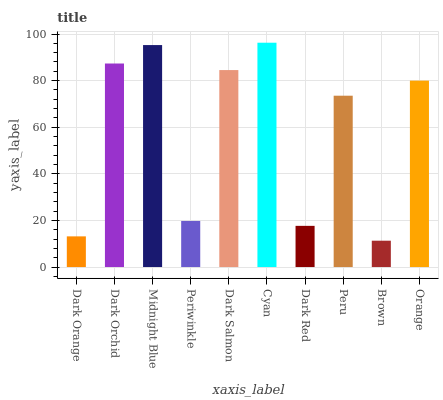Is Brown the minimum?
Answer yes or no. Yes. Is Cyan the maximum?
Answer yes or no. Yes. Is Dark Orchid the minimum?
Answer yes or no. No. Is Dark Orchid the maximum?
Answer yes or no. No. Is Dark Orchid greater than Dark Orange?
Answer yes or no. Yes. Is Dark Orange less than Dark Orchid?
Answer yes or no. Yes. Is Dark Orange greater than Dark Orchid?
Answer yes or no. No. Is Dark Orchid less than Dark Orange?
Answer yes or no. No. Is Orange the high median?
Answer yes or no. Yes. Is Peru the low median?
Answer yes or no. Yes. Is Brown the high median?
Answer yes or no. No. Is Midnight Blue the low median?
Answer yes or no. No. 